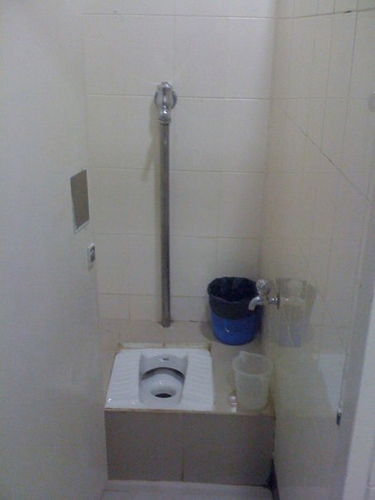<image>What country is this likely to be located in? It is ambiguous to determine the country this is likely located in. The answers vary quite widely from 'europe' to 'united states' and 'japan'. What country is this likely to be located in? I don't know what country this is likely to be located in. It can be Europe, United States, Japan, China, Iraq or India. 